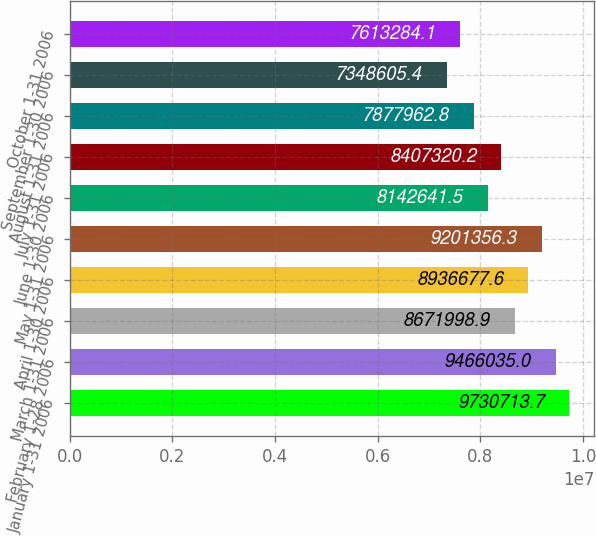Convert chart. <chart><loc_0><loc_0><loc_500><loc_500><bar_chart><fcel>January 1-31 2006<fcel>February 1-28 2006<fcel>March 1-31 2006<fcel>April 1-30 2006<fcel>May 1-31 2006<fcel>June 1-30 2006<fcel>July 1-31 2006<fcel>August 1-31 2006<fcel>September 1-30 2006<fcel>October 1-31 2006<nl><fcel>9.73071e+06<fcel>9.46604e+06<fcel>8.672e+06<fcel>8.93668e+06<fcel>9.20136e+06<fcel>8.14264e+06<fcel>8.40732e+06<fcel>7.87796e+06<fcel>7.34861e+06<fcel>7.61328e+06<nl></chart> 